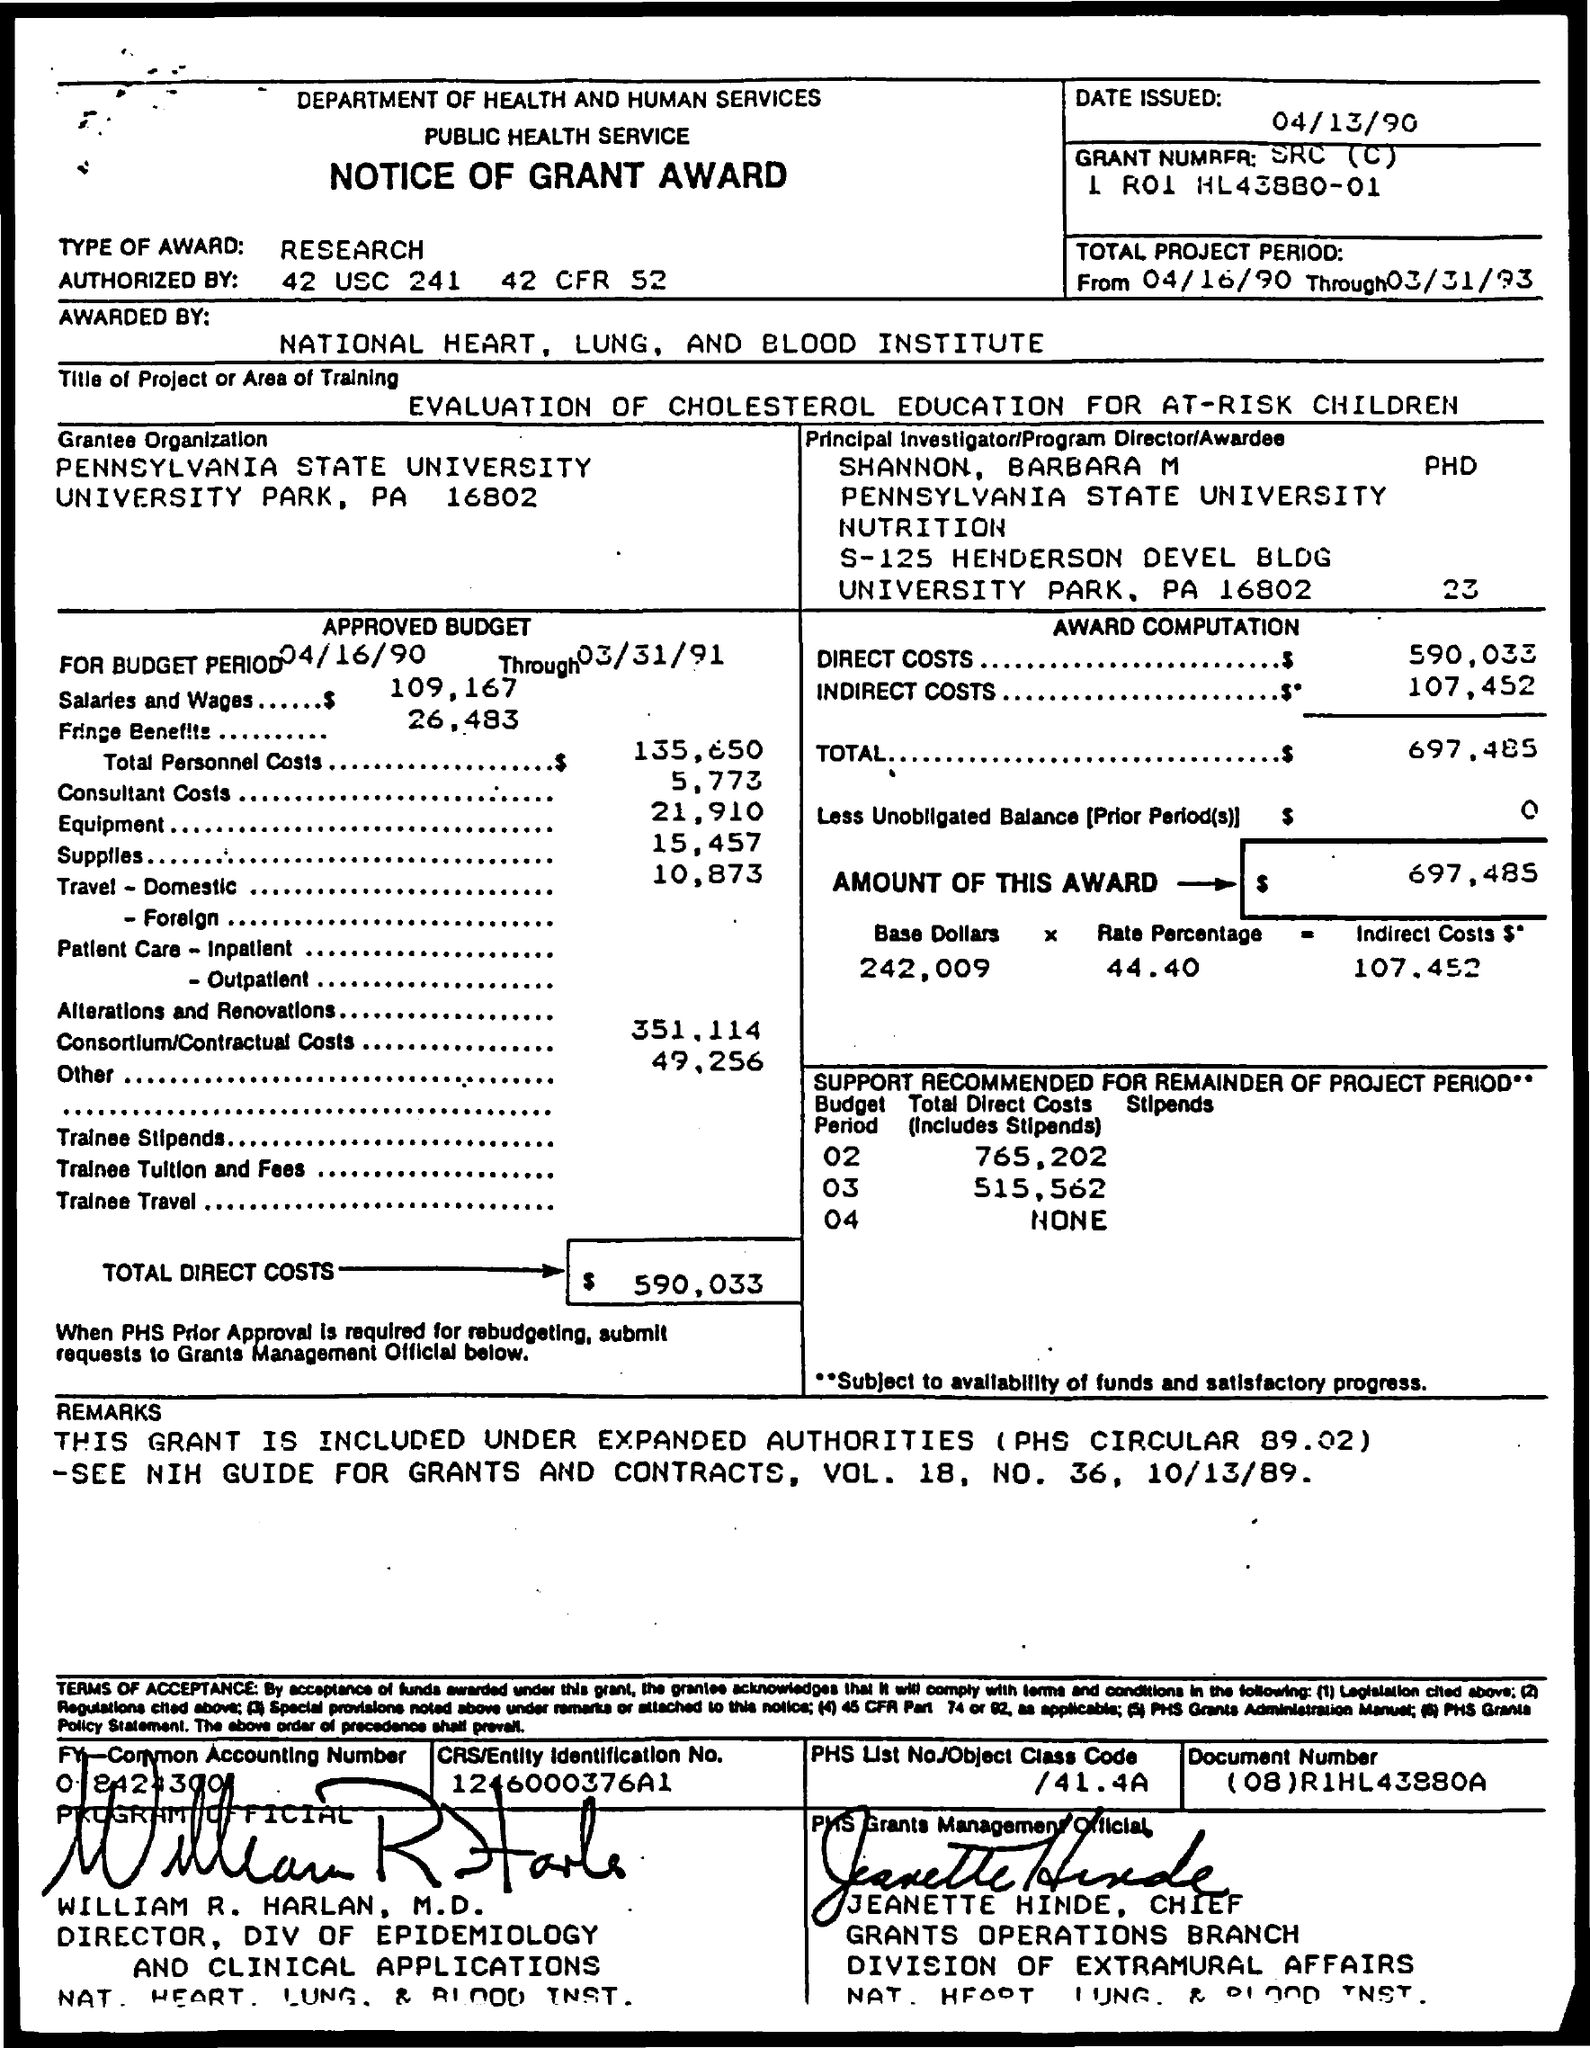Can you tell me the institution that received this grant? The institution that received the grant is Pennsylvania State University, located in University Park, PA.  What is the total budget approved for the project? The total approved budget for the project is $697,485, as outlined in the 'Notice of Grant Award' document. 